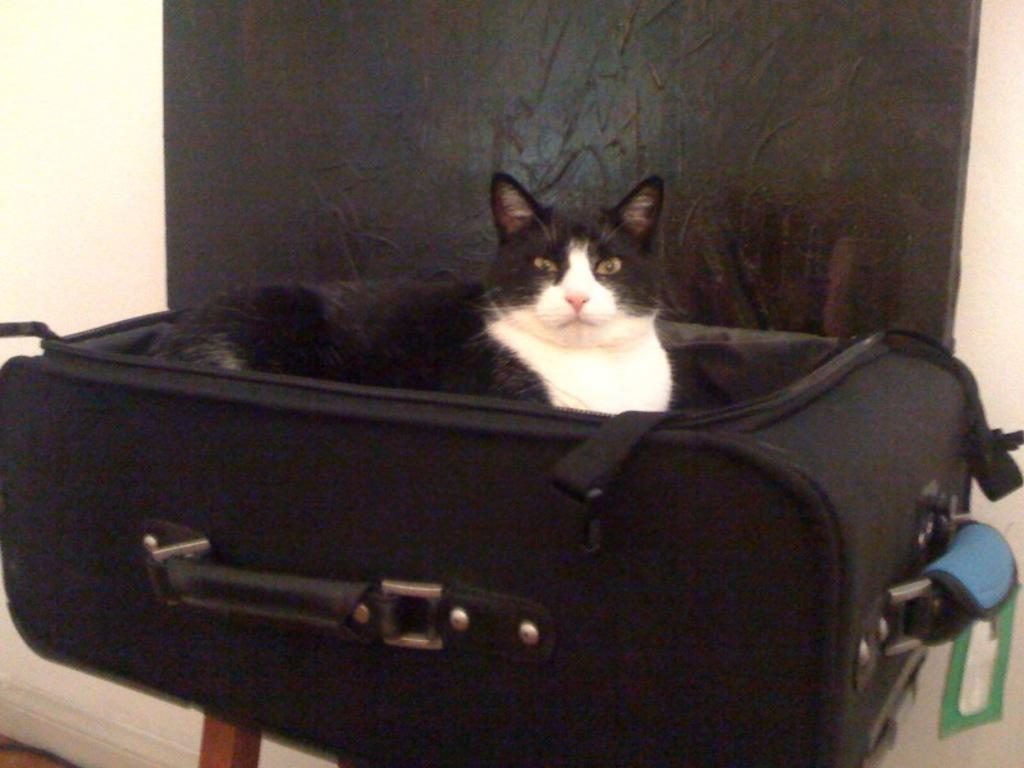What is inside the luggage trolley in the image? There is a cat in the luggage trolley. Where is the luggage trolley located? The luggage trolley is placed on a table. What can be seen in the background of the image? There is a wall in the background of the image. What type of toothbrush is the cat using in the image? There is no toothbrush present in the image, and the cat is not using one. 